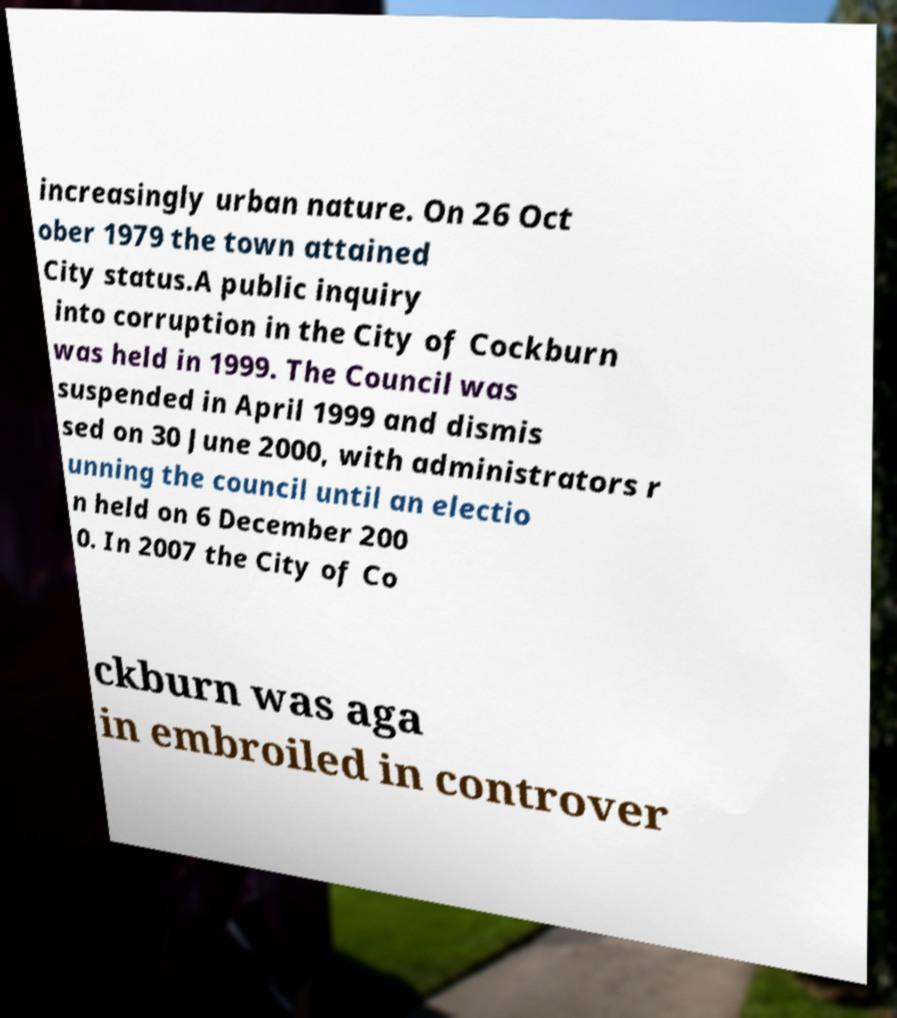Please read and relay the text visible in this image. What does it say? increasingly urban nature. On 26 Oct ober 1979 the town attained City status.A public inquiry into corruption in the City of Cockburn was held in 1999. The Council was suspended in April 1999 and dismis sed on 30 June 2000, with administrators r unning the council until an electio n held on 6 December 200 0. In 2007 the City of Co ckburn was aga in embroiled in controver 